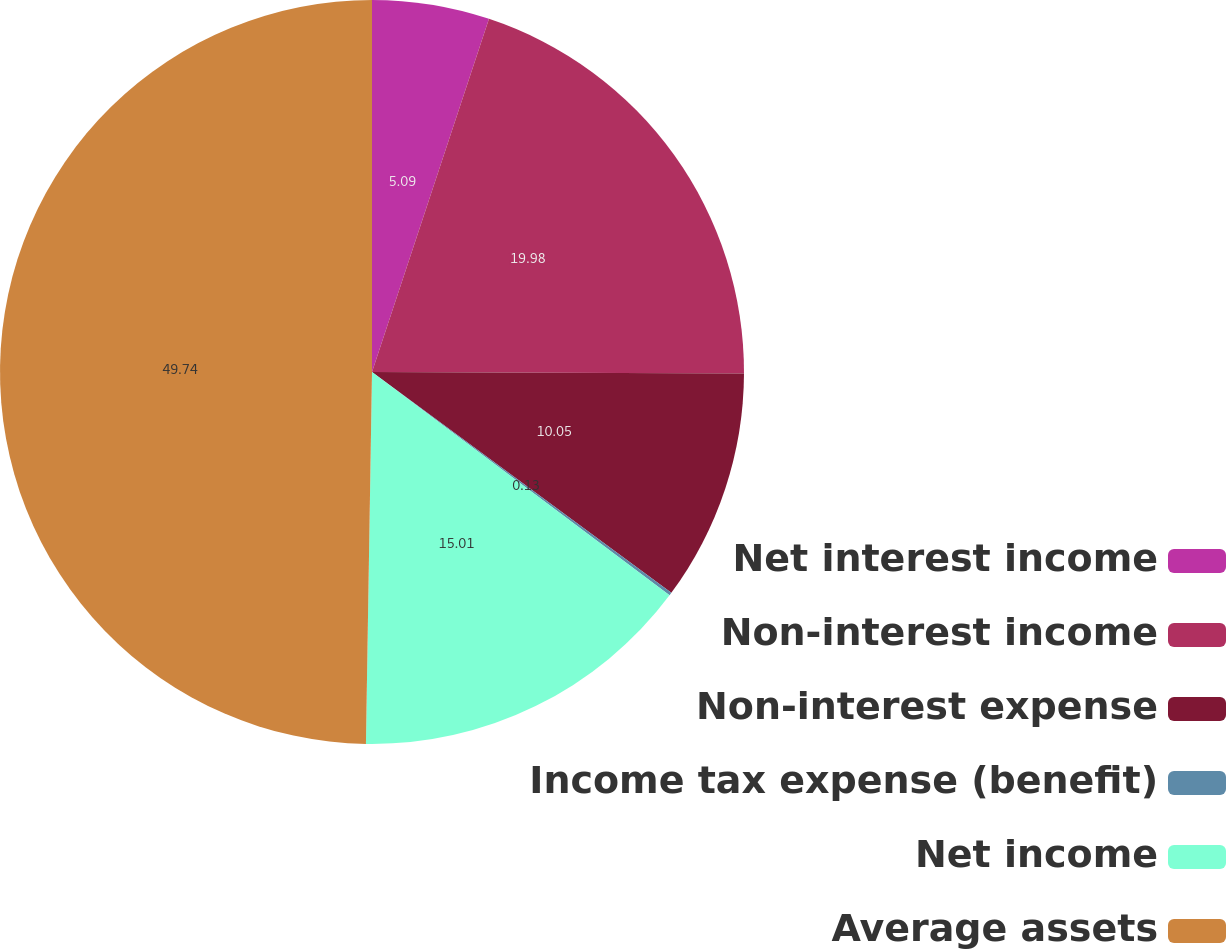Convert chart to OTSL. <chart><loc_0><loc_0><loc_500><loc_500><pie_chart><fcel>Net interest income<fcel>Non-interest income<fcel>Non-interest expense<fcel>Income tax expense (benefit)<fcel>Net income<fcel>Average assets<nl><fcel>5.09%<fcel>19.97%<fcel>10.05%<fcel>0.13%<fcel>15.01%<fcel>49.73%<nl></chart> 